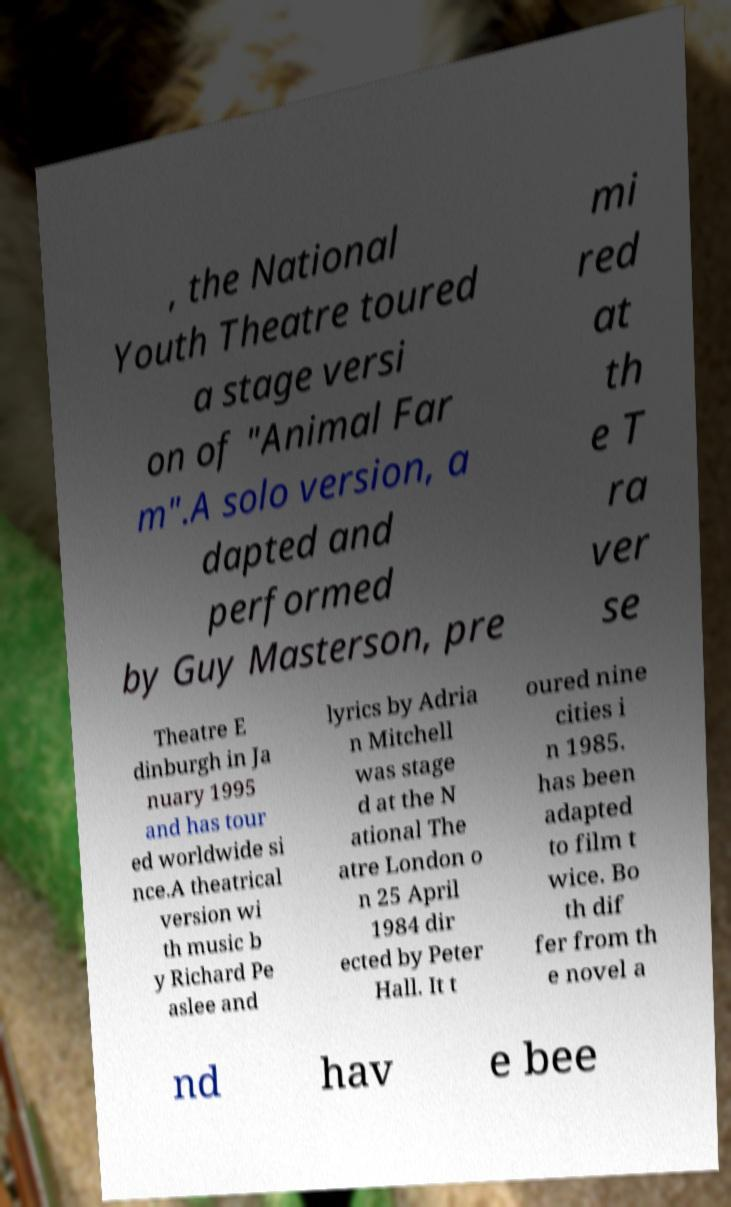There's text embedded in this image that I need extracted. Can you transcribe it verbatim? , the National Youth Theatre toured a stage versi on of "Animal Far m".A solo version, a dapted and performed by Guy Masterson, pre mi red at th e T ra ver se Theatre E dinburgh in Ja nuary 1995 and has tour ed worldwide si nce.A theatrical version wi th music b y Richard Pe aslee and lyrics by Adria n Mitchell was stage d at the N ational The atre London o n 25 April 1984 dir ected by Peter Hall. It t oured nine cities i n 1985. has been adapted to film t wice. Bo th dif fer from th e novel a nd hav e bee 